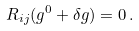Convert formula to latex. <formula><loc_0><loc_0><loc_500><loc_500>R _ { i j } ( g ^ { 0 } + \delta g ) = 0 \, .</formula> 